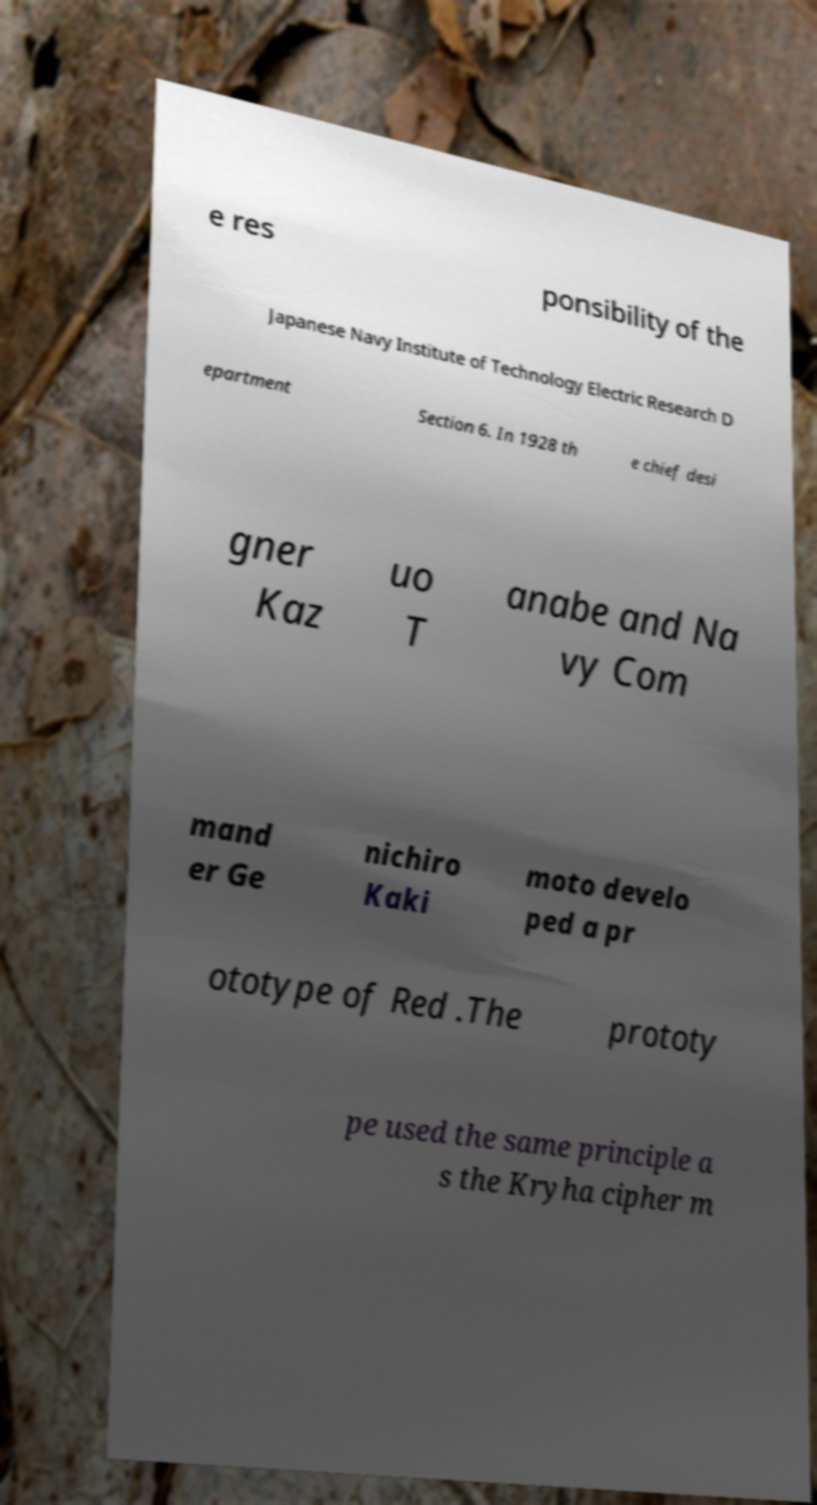Can you read and provide the text displayed in the image?This photo seems to have some interesting text. Can you extract and type it out for me? e res ponsibility of the Japanese Navy Institute of Technology Electric Research D epartment Section 6. In 1928 th e chief desi gner Kaz uo T anabe and Na vy Com mand er Ge nichiro Kaki moto develo ped a pr ototype of Red .The prototy pe used the same principle a s the Kryha cipher m 